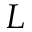<formula> <loc_0><loc_0><loc_500><loc_500>L</formula> 